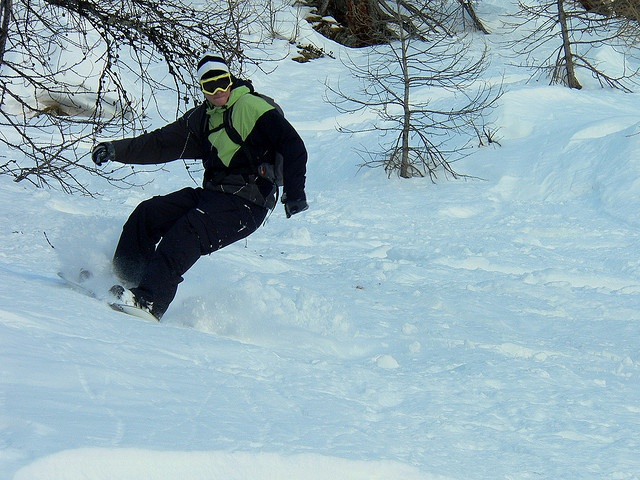Describe the objects in this image and their specific colors. I can see people in beige, black, gray, green, and lightblue tones, backpack in beige, black, green, and darkgreen tones, and snowboard in beige, darkgray, gray, and lightblue tones in this image. 